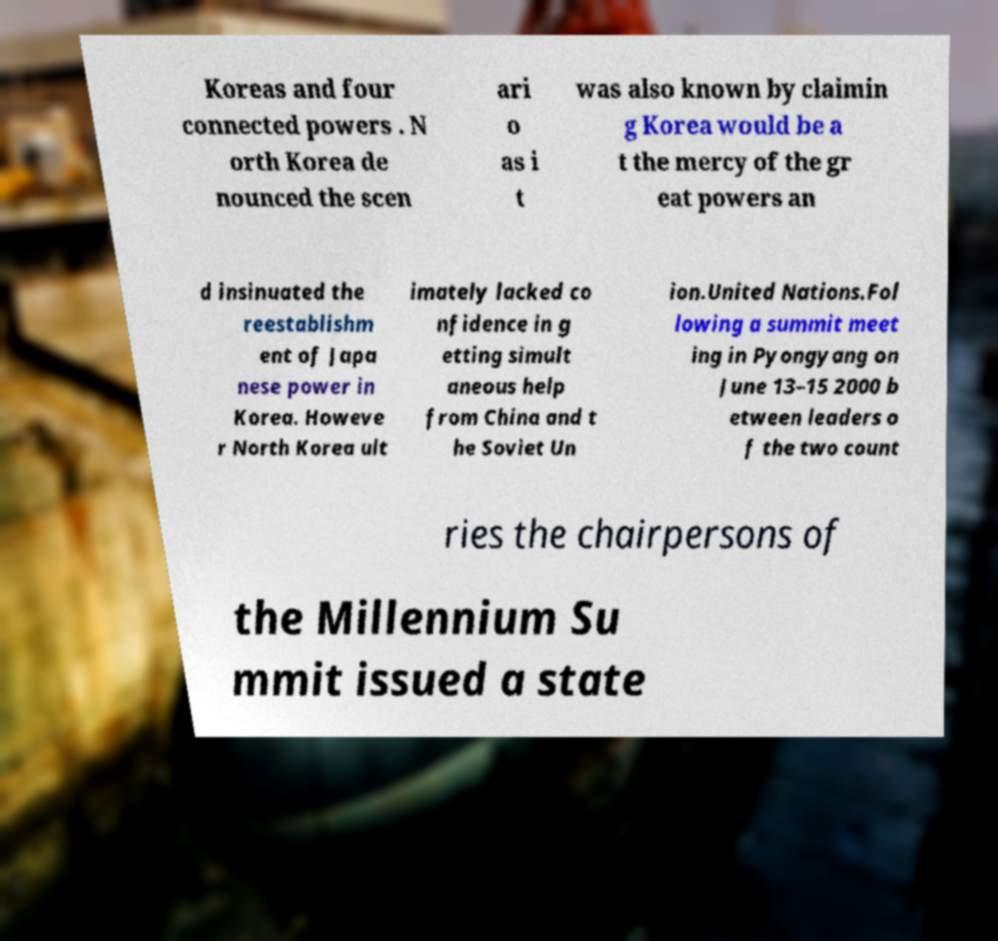I need the written content from this picture converted into text. Can you do that? Koreas and four connected powers . N orth Korea de nounced the scen ari o as i t was also known by claimin g Korea would be a t the mercy of the gr eat powers an d insinuated the reestablishm ent of Japa nese power in Korea. Howeve r North Korea ult imately lacked co nfidence in g etting simult aneous help from China and t he Soviet Un ion.United Nations.Fol lowing a summit meet ing in Pyongyang on June 13–15 2000 b etween leaders o f the two count ries the chairpersons of the Millennium Su mmit issued a state 